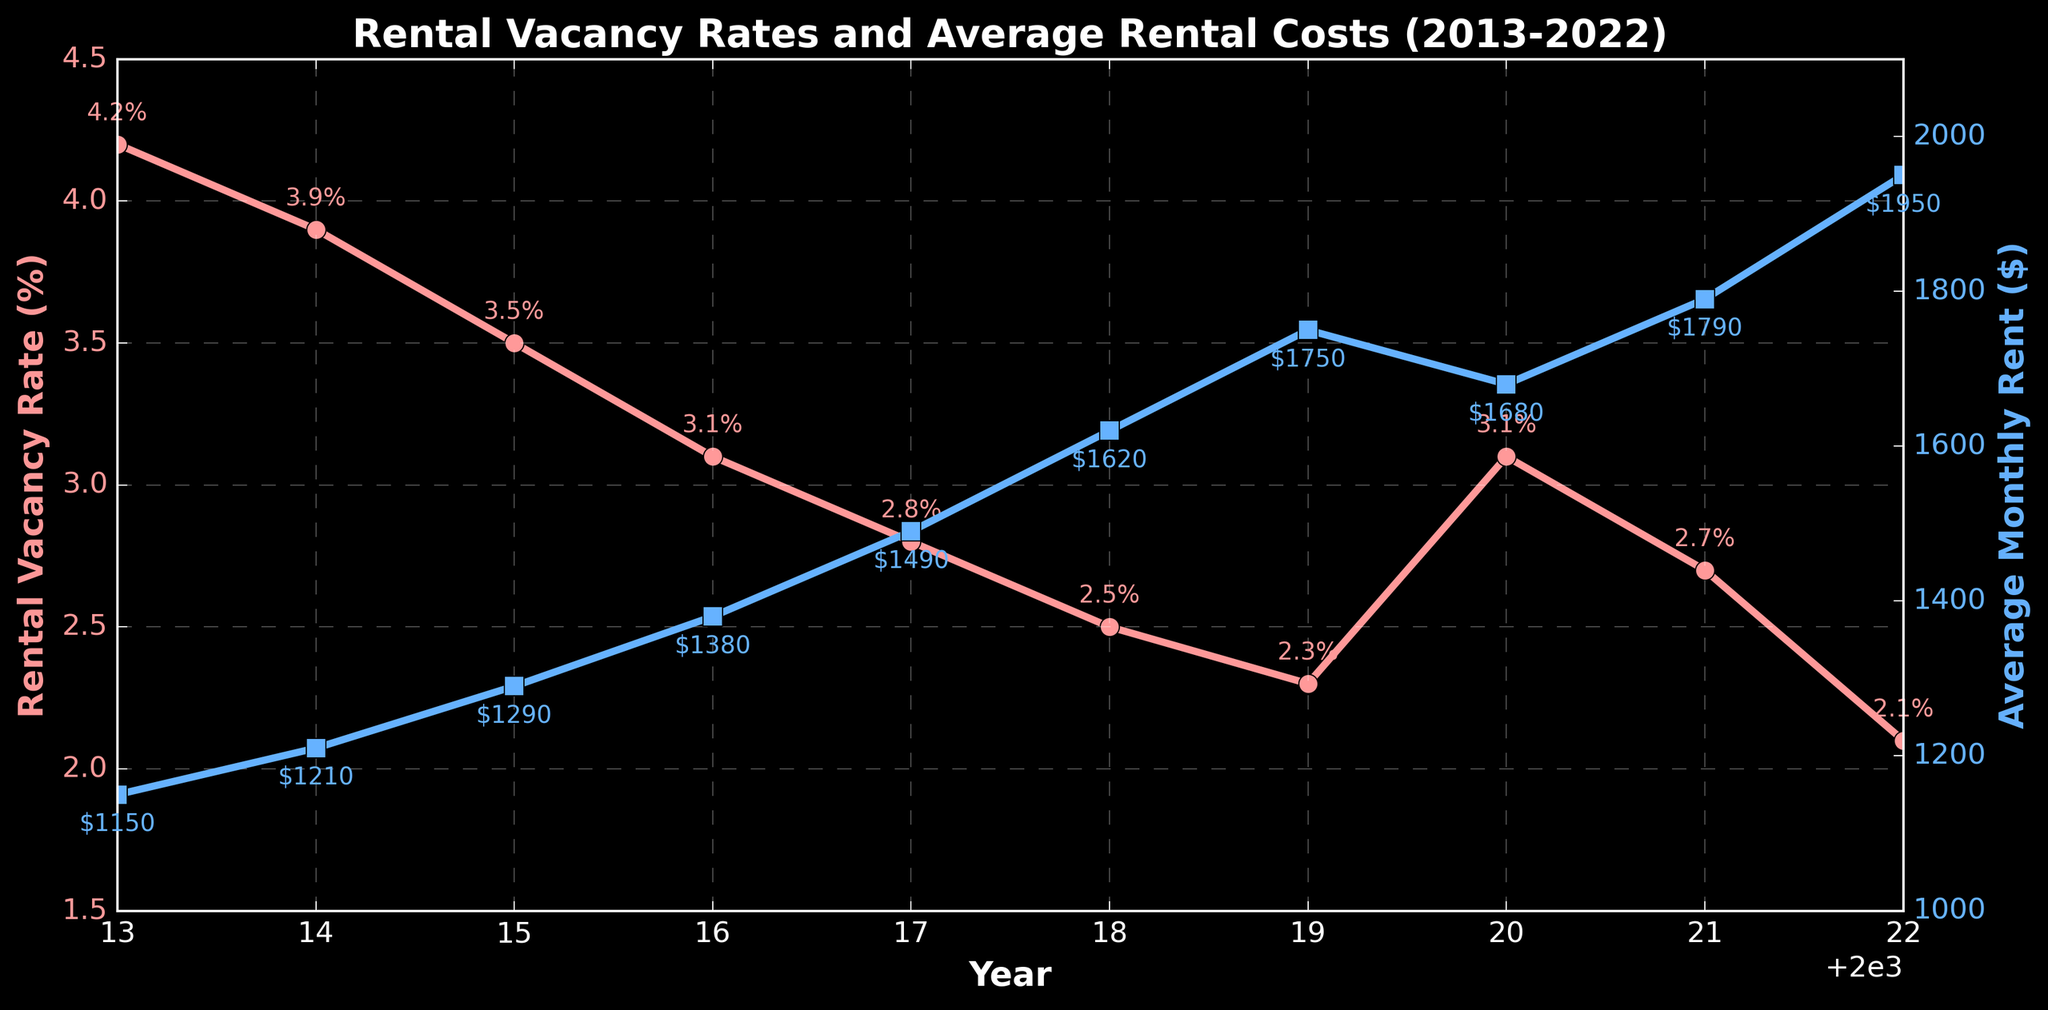Why did the Rental Vacancy Rate increase from 2019 to 2020? From 2019 to 2020, the Rental Vacancy Rate increased from 2.3% to 3.1%. This can be observed directly on the line chart where the rate for 2020 is higher than the rate for 2019.
Answer: Due to the increase in the Rental Vacancy Rate What was the trend in Average Monthly Rent from 2013 to 2022? The Average Monthly Rent shows a general upward trend from 2013 to 2022. Specifically, it increases every year from $1150 in 2013 to $1950 in 2022.
Answer: Upward trend Which year had the lowest Rental Vacancy Rate? Observing the line chart for Rental Vacancy Rates, the lowest rate is noted in 2022, at 2.1%.
Answer: 2022 How did the Rental Vacancy Rate change from 2016 to 2017? The Rental Vacancy Rate decreased from 3.1% in 2016 to 2.8% in 2017. This is a drop of 0.3 percentage points.
Answer: Decreased by 0.3 percentage points What is the difference in Average Monthly Rent between 2013 and 2022? The Average Monthly Rent increased from $1150 in 2013 to $1950 in 2022. The difference is $1950 - $1150 = $800.
Answer: $800 What is the average Rental Vacancy Rate from 2013 to 2022? Sum the Rental Vacancy Rates from each year and divide by the total number of years. (4.2 + 3.9 + 3.5 + 3.1 + 2.8 + 2.5 + 2.3 + 3.1 + 2.7 + 2.1) / 10 = 3.02%.
Answer: 3.02% What is the percentage growth in Average Monthly Rent from 2015 to 2022? Calculate percentage growth as ((Rent in 2022 - Rent in 2015) / Rent in 2015) * 100. That gives ((1950 - 1290) / 1290) * 100 = 51.16%.
Answer: 51.16% By how much did the Average Monthly Rent increase from 2018 to 2019? The Average Monthly Rent increased from $1620 in 2018 to $1750 in 2019. The increase is $1750 - $1620 = $130.
Answer: $130 Which year saw the steepest decline in Rental Vacancy Rate? By comparing the year-over-year changes, the largest decline occurs between 2019 (2.3%) and 2018 (2.5%), which is a decline of 0.7 percentage points.
Answer: Between 2019 and 2018 How much did the Rental Vacancy Rate increase from 2021 to 2022? Observing the line chart, the Rental Vacancy Rate decreased from 2.7% in 2021 to 2.1% in 2022, so it did not increase; it actually decreased.
Answer: It didn't increase; it decreased 